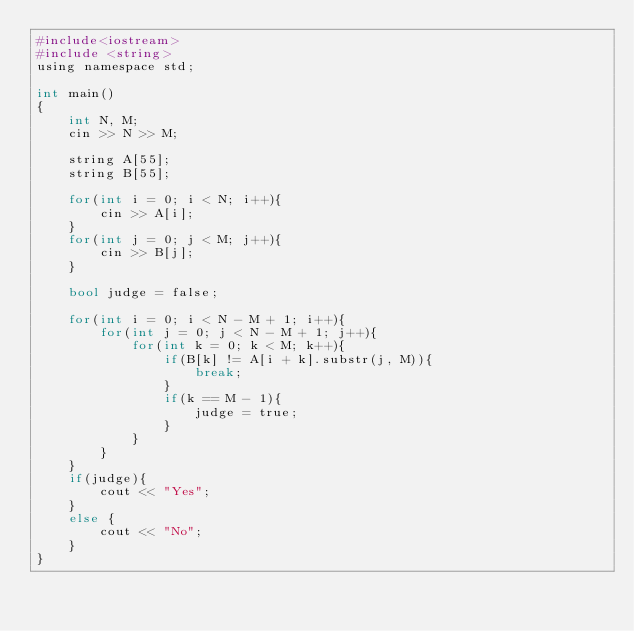Convert code to text. <code><loc_0><loc_0><loc_500><loc_500><_Python_>#include<iostream>
#include <string>
using namespace std;

int main()
{
	int N, M;
	cin >> N >> M;
	
	string A[55];
	string B[55];
	
	for(int i = 0; i < N; i++){
		cin >> A[i];
	}
	for(int j = 0; j < M; j++){
		cin >> B[j];
	}
	
	bool judge = false;
	
	for(int i = 0; i < N - M + 1; i++){
		for(int j = 0; j < N - M + 1; j++){
			for(int k = 0; k < M; k++){
				if(B[k] != A[i + k].substr(j, M)){
					break;
				}
				if(k == M - 1){
					judge = true;
				}
			}
		}
	}
	if(judge){
		cout << "Yes";
	}
	else {
		cout << "No";
	}
}
</code> 